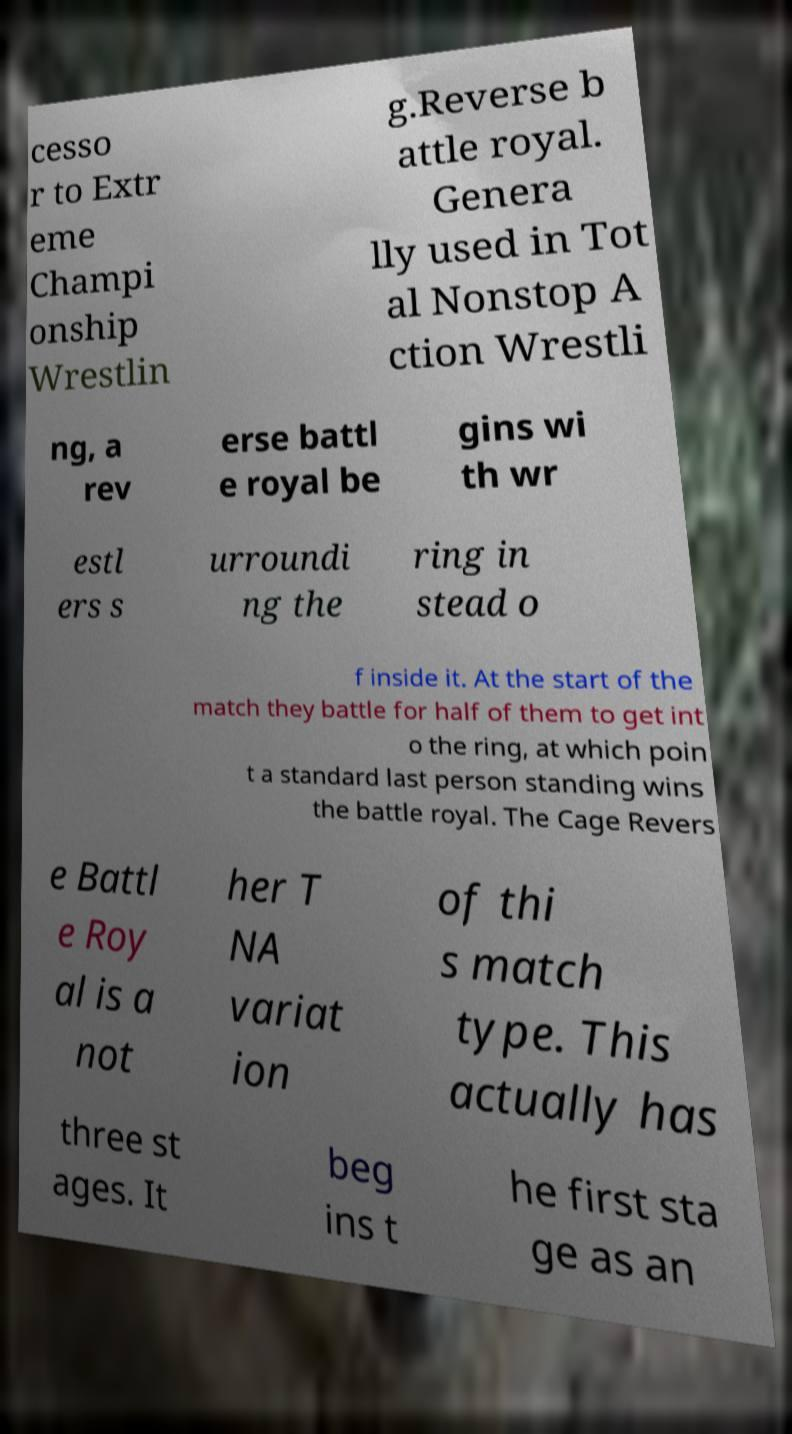Please read and relay the text visible in this image. What does it say? cesso r to Extr eme Champi onship Wrestlin g.Reverse b attle royal. Genera lly used in Tot al Nonstop A ction Wrestli ng, a rev erse battl e royal be gins wi th wr estl ers s urroundi ng the ring in stead o f inside it. At the start of the match they battle for half of them to get int o the ring, at which poin t a standard last person standing wins the battle royal. The Cage Revers e Battl e Roy al is a not her T NA variat ion of thi s match type. This actually has three st ages. It beg ins t he first sta ge as an 